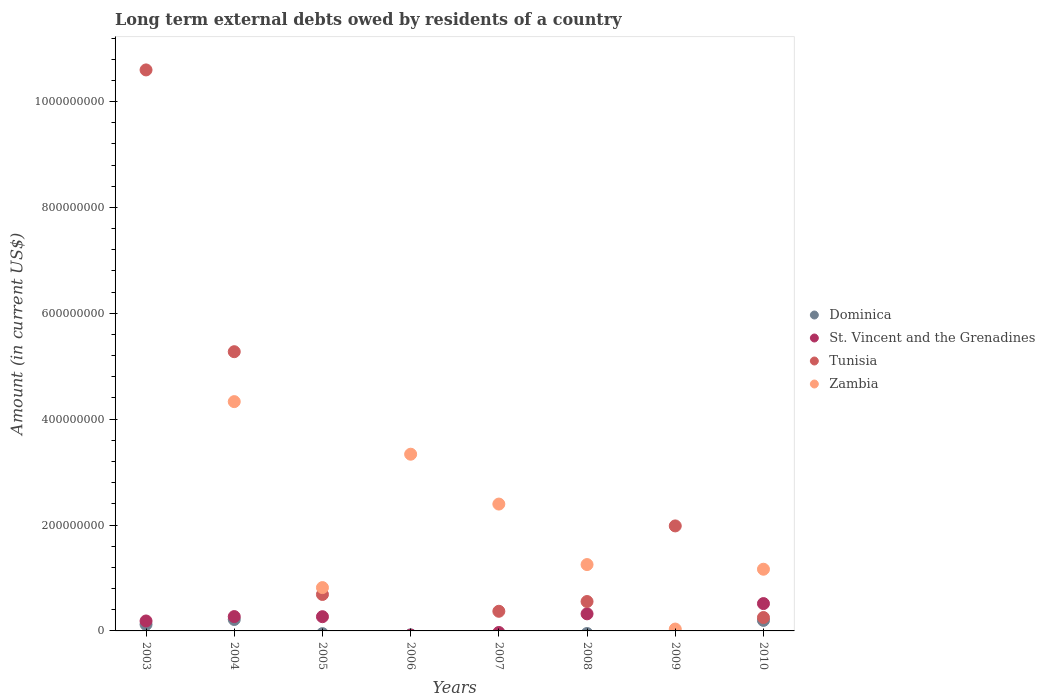Is the number of dotlines equal to the number of legend labels?
Your response must be concise. No. Across all years, what is the maximum amount of long-term external debts owed by residents in Zambia?
Your response must be concise. 4.33e+08. What is the total amount of long-term external debts owed by residents in Dominica in the graph?
Give a very brief answer. 5.37e+07. What is the difference between the amount of long-term external debts owed by residents in Zambia in 2005 and that in 2008?
Offer a terse response. -4.35e+07. What is the difference between the amount of long-term external debts owed by residents in Tunisia in 2008 and the amount of long-term external debts owed by residents in Zambia in 2009?
Provide a short and direct response. 5.20e+07. What is the average amount of long-term external debts owed by residents in Zambia per year?
Keep it short and to the point. 1.67e+08. In the year 2003, what is the difference between the amount of long-term external debts owed by residents in Tunisia and amount of long-term external debts owed by residents in Dominica?
Give a very brief answer. 1.05e+09. What is the ratio of the amount of long-term external debts owed by residents in Tunisia in 2004 to that in 2007?
Keep it short and to the point. 14.21. What is the difference between the highest and the second highest amount of long-term external debts owed by residents in Tunisia?
Ensure brevity in your answer.  5.32e+08. What is the difference between the highest and the lowest amount of long-term external debts owed by residents in Zambia?
Give a very brief answer. 4.33e+08. Is it the case that in every year, the sum of the amount of long-term external debts owed by residents in Tunisia and amount of long-term external debts owed by residents in St. Vincent and the Grenadines  is greater than the sum of amount of long-term external debts owed by residents in Zambia and amount of long-term external debts owed by residents in Dominica?
Keep it short and to the point. No. Is it the case that in every year, the sum of the amount of long-term external debts owed by residents in Tunisia and amount of long-term external debts owed by residents in Dominica  is greater than the amount of long-term external debts owed by residents in Zambia?
Offer a very short reply. No. Does the amount of long-term external debts owed by residents in Tunisia monotonically increase over the years?
Provide a short and direct response. No. How many dotlines are there?
Keep it short and to the point. 4. How are the legend labels stacked?
Ensure brevity in your answer.  Vertical. What is the title of the graph?
Your answer should be very brief. Long term external debts owed by residents of a country. What is the label or title of the Y-axis?
Offer a terse response. Amount (in current US$). What is the Amount (in current US$) in Dominica in 2003?
Make the answer very short. 1.23e+07. What is the Amount (in current US$) of St. Vincent and the Grenadines in 2003?
Your response must be concise. 1.88e+07. What is the Amount (in current US$) in Tunisia in 2003?
Your response must be concise. 1.06e+09. What is the Amount (in current US$) of Dominica in 2004?
Provide a succinct answer. 2.16e+07. What is the Amount (in current US$) in St. Vincent and the Grenadines in 2004?
Give a very brief answer. 2.71e+07. What is the Amount (in current US$) of Tunisia in 2004?
Keep it short and to the point. 5.27e+08. What is the Amount (in current US$) of Zambia in 2004?
Provide a short and direct response. 4.33e+08. What is the Amount (in current US$) of St. Vincent and the Grenadines in 2005?
Make the answer very short. 2.69e+07. What is the Amount (in current US$) in Tunisia in 2005?
Give a very brief answer. 6.89e+07. What is the Amount (in current US$) in Zambia in 2005?
Offer a terse response. 8.18e+07. What is the Amount (in current US$) in Dominica in 2006?
Your answer should be compact. 0. What is the Amount (in current US$) of St. Vincent and the Grenadines in 2006?
Offer a terse response. 0. What is the Amount (in current US$) of Zambia in 2006?
Provide a succinct answer. 3.34e+08. What is the Amount (in current US$) in Tunisia in 2007?
Give a very brief answer. 3.71e+07. What is the Amount (in current US$) in Zambia in 2007?
Provide a short and direct response. 2.40e+08. What is the Amount (in current US$) of Dominica in 2008?
Give a very brief answer. 0. What is the Amount (in current US$) of St. Vincent and the Grenadines in 2008?
Provide a succinct answer. 3.23e+07. What is the Amount (in current US$) of Tunisia in 2008?
Your response must be concise. 5.55e+07. What is the Amount (in current US$) of Zambia in 2008?
Your answer should be very brief. 1.25e+08. What is the Amount (in current US$) of St. Vincent and the Grenadines in 2009?
Give a very brief answer. 0. What is the Amount (in current US$) in Tunisia in 2009?
Make the answer very short. 1.98e+08. What is the Amount (in current US$) of Zambia in 2009?
Offer a very short reply. 3.52e+06. What is the Amount (in current US$) of Dominica in 2010?
Provide a succinct answer. 1.99e+07. What is the Amount (in current US$) in St. Vincent and the Grenadines in 2010?
Ensure brevity in your answer.  5.17e+07. What is the Amount (in current US$) in Tunisia in 2010?
Your response must be concise. 2.53e+07. What is the Amount (in current US$) of Zambia in 2010?
Your answer should be very brief. 1.17e+08. Across all years, what is the maximum Amount (in current US$) in Dominica?
Your answer should be very brief. 2.16e+07. Across all years, what is the maximum Amount (in current US$) of St. Vincent and the Grenadines?
Make the answer very short. 5.17e+07. Across all years, what is the maximum Amount (in current US$) in Tunisia?
Provide a short and direct response. 1.06e+09. Across all years, what is the maximum Amount (in current US$) in Zambia?
Provide a succinct answer. 4.33e+08. Across all years, what is the minimum Amount (in current US$) in Tunisia?
Offer a terse response. 0. What is the total Amount (in current US$) in Dominica in the graph?
Provide a succinct answer. 5.37e+07. What is the total Amount (in current US$) in St. Vincent and the Grenadines in the graph?
Give a very brief answer. 1.57e+08. What is the total Amount (in current US$) of Tunisia in the graph?
Give a very brief answer. 1.97e+09. What is the total Amount (in current US$) of Zambia in the graph?
Give a very brief answer. 1.33e+09. What is the difference between the Amount (in current US$) of Dominica in 2003 and that in 2004?
Give a very brief answer. -9.34e+06. What is the difference between the Amount (in current US$) in St. Vincent and the Grenadines in 2003 and that in 2004?
Your response must be concise. -8.30e+06. What is the difference between the Amount (in current US$) in Tunisia in 2003 and that in 2004?
Make the answer very short. 5.32e+08. What is the difference between the Amount (in current US$) in St. Vincent and the Grenadines in 2003 and that in 2005?
Your response must be concise. -8.10e+06. What is the difference between the Amount (in current US$) of Tunisia in 2003 and that in 2005?
Provide a succinct answer. 9.91e+08. What is the difference between the Amount (in current US$) of Tunisia in 2003 and that in 2007?
Your answer should be compact. 1.02e+09. What is the difference between the Amount (in current US$) of St. Vincent and the Grenadines in 2003 and that in 2008?
Ensure brevity in your answer.  -1.35e+07. What is the difference between the Amount (in current US$) in Tunisia in 2003 and that in 2008?
Give a very brief answer. 1.00e+09. What is the difference between the Amount (in current US$) of Tunisia in 2003 and that in 2009?
Make the answer very short. 8.61e+08. What is the difference between the Amount (in current US$) of Dominica in 2003 and that in 2010?
Your answer should be very brief. -7.62e+06. What is the difference between the Amount (in current US$) in St. Vincent and the Grenadines in 2003 and that in 2010?
Your response must be concise. -3.29e+07. What is the difference between the Amount (in current US$) in Tunisia in 2003 and that in 2010?
Provide a short and direct response. 1.03e+09. What is the difference between the Amount (in current US$) of St. Vincent and the Grenadines in 2004 and that in 2005?
Keep it short and to the point. 1.99e+05. What is the difference between the Amount (in current US$) of Tunisia in 2004 and that in 2005?
Make the answer very short. 4.59e+08. What is the difference between the Amount (in current US$) in Zambia in 2004 and that in 2005?
Your answer should be very brief. 3.51e+08. What is the difference between the Amount (in current US$) of Zambia in 2004 and that in 2006?
Provide a succinct answer. 9.93e+07. What is the difference between the Amount (in current US$) of Tunisia in 2004 and that in 2007?
Keep it short and to the point. 4.90e+08. What is the difference between the Amount (in current US$) of Zambia in 2004 and that in 2007?
Your answer should be very brief. 1.94e+08. What is the difference between the Amount (in current US$) in St. Vincent and the Grenadines in 2004 and that in 2008?
Keep it short and to the point. -5.20e+06. What is the difference between the Amount (in current US$) in Tunisia in 2004 and that in 2008?
Offer a terse response. 4.72e+08. What is the difference between the Amount (in current US$) of Zambia in 2004 and that in 2008?
Make the answer very short. 3.08e+08. What is the difference between the Amount (in current US$) in Tunisia in 2004 and that in 2009?
Keep it short and to the point. 3.29e+08. What is the difference between the Amount (in current US$) of Zambia in 2004 and that in 2009?
Your response must be concise. 4.30e+08. What is the difference between the Amount (in current US$) in Dominica in 2004 and that in 2010?
Provide a succinct answer. 1.71e+06. What is the difference between the Amount (in current US$) of St. Vincent and the Grenadines in 2004 and that in 2010?
Keep it short and to the point. -2.46e+07. What is the difference between the Amount (in current US$) of Tunisia in 2004 and that in 2010?
Give a very brief answer. 5.02e+08. What is the difference between the Amount (in current US$) of Zambia in 2004 and that in 2010?
Your answer should be very brief. 3.17e+08. What is the difference between the Amount (in current US$) of Zambia in 2005 and that in 2006?
Your response must be concise. -2.52e+08. What is the difference between the Amount (in current US$) in Tunisia in 2005 and that in 2007?
Provide a short and direct response. 3.18e+07. What is the difference between the Amount (in current US$) in Zambia in 2005 and that in 2007?
Ensure brevity in your answer.  -1.58e+08. What is the difference between the Amount (in current US$) in St. Vincent and the Grenadines in 2005 and that in 2008?
Give a very brief answer. -5.40e+06. What is the difference between the Amount (in current US$) in Tunisia in 2005 and that in 2008?
Offer a very short reply. 1.33e+07. What is the difference between the Amount (in current US$) of Zambia in 2005 and that in 2008?
Make the answer very short. -4.35e+07. What is the difference between the Amount (in current US$) in Tunisia in 2005 and that in 2009?
Offer a terse response. -1.29e+08. What is the difference between the Amount (in current US$) in Zambia in 2005 and that in 2009?
Ensure brevity in your answer.  7.83e+07. What is the difference between the Amount (in current US$) in St. Vincent and the Grenadines in 2005 and that in 2010?
Keep it short and to the point. -2.48e+07. What is the difference between the Amount (in current US$) in Tunisia in 2005 and that in 2010?
Keep it short and to the point. 4.36e+07. What is the difference between the Amount (in current US$) in Zambia in 2005 and that in 2010?
Give a very brief answer. -3.47e+07. What is the difference between the Amount (in current US$) of Zambia in 2006 and that in 2007?
Ensure brevity in your answer.  9.42e+07. What is the difference between the Amount (in current US$) of Zambia in 2006 and that in 2008?
Keep it short and to the point. 2.08e+08. What is the difference between the Amount (in current US$) in Zambia in 2006 and that in 2009?
Keep it short and to the point. 3.30e+08. What is the difference between the Amount (in current US$) of Zambia in 2006 and that in 2010?
Offer a very short reply. 2.17e+08. What is the difference between the Amount (in current US$) of Tunisia in 2007 and that in 2008?
Ensure brevity in your answer.  -1.84e+07. What is the difference between the Amount (in current US$) in Zambia in 2007 and that in 2008?
Ensure brevity in your answer.  1.14e+08. What is the difference between the Amount (in current US$) in Tunisia in 2007 and that in 2009?
Provide a succinct answer. -1.61e+08. What is the difference between the Amount (in current US$) of Zambia in 2007 and that in 2009?
Give a very brief answer. 2.36e+08. What is the difference between the Amount (in current US$) of Tunisia in 2007 and that in 2010?
Keep it short and to the point. 1.18e+07. What is the difference between the Amount (in current US$) in Zambia in 2007 and that in 2010?
Offer a very short reply. 1.23e+08. What is the difference between the Amount (in current US$) in Tunisia in 2008 and that in 2009?
Provide a short and direct response. -1.43e+08. What is the difference between the Amount (in current US$) in Zambia in 2008 and that in 2009?
Offer a terse response. 1.22e+08. What is the difference between the Amount (in current US$) of St. Vincent and the Grenadines in 2008 and that in 2010?
Offer a terse response. -1.94e+07. What is the difference between the Amount (in current US$) in Tunisia in 2008 and that in 2010?
Offer a very short reply. 3.02e+07. What is the difference between the Amount (in current US$) of Zambia in 2008 and that in 2010?
Offer a terse response. 8.81e+06. What is the difference between the Amount (in current US$) in Tunisia in 2009 and that in 2010?
Offer a very short reply. 1.73e+08. What is the difference between the Amount (in current US$) of Zambia in 2009 and that in 2010?
Provide a short and direct response. -1.13e+08. What is the difference between the Amount (in current US$) in Dominica in 2003 and the Amount (in current US$) in St. Vincent and the Grenadines in 2004?
Your answer should be compact. -1.48e+07. What is the difference between the Amount (in current US$) in Dominica in 2003 and the Amount (in current US$) in Tunisia in 2004?
Your answer should be very brief. -5.15e+08. What is the difference between the Amount (in current US$) of Dominica in 2003 and the Amount (in current US$) of Zambia in 2004?
Provide a succinct answer. -4.21e+08. What is the difference between the Amount (in current US$) in St. Vincent and the Grenadines in 2003 and the Amount (in current US$) in Tunisia in 2004?
Give a very brief answer. -5.09e+08. What is the difference between the Amount (in current US$) in St. Vincent and the Grenadines in 2003 and the Amount (in current US$) in Zambia in 2004?
Provide a succinct answer. -4.14e+08. What is the difference between the Amount (in current US$) in Tunisia in 2003 and the Amount (in current US$) in Zambia in 2004?
Offer a terse response. 6.27e+08. What is the difference between the Amount (in current US$) of Dominica in 2003 and the Amount (in current US$) of St. Vincent and the Grenadines in 2005?
Offer a terse response. -1.46e+07. What is the difference between the Amount (in current US$) in Dominica in 2003 and the Amount (in current US$) in Tunisia in 2005?
Give a very brief answer. -5.66e+07. What is the difference between the Amount (in current US$) of Dominica in 2003 and the Amount (in current US$) of Zambia in 2005?
Provide a succinct answer. -6.96e+07. What is the difference between the Amount (in current US$) of St. Vincent and the Grenadines in 2003 and the Amount (in current US$) of Tunisia in 2005?
Offer a very short reply. -5.01e+07. What is the difference between the Amount (in current US$) of St. Vincent and the Grenadines in 2003 and the Amount (in current US$) of Zambia in 2005?
Offer a terse response. -6.31e+07. What is the difference between the Amount (in current US$) of Tunisia in 2003 and the Amount (in current US$) of Zambia in 2005?
Offer a very short reply. 9.78e+08. What is the difference between the Amount (in current US$) of Dominica in 2003 and the Amount (in current US$) of Zambia in 2006?
Your response must be concise. -3.22e+08. What is the difference between the Amount (in current US$) in St. Vincent and the Grenadines in 2003 and the Amount (in current US$) in Zambia in 2006?
Make the answer very short. -3.15e+08. What is the difference between the Amount (in current US$) in Tunisia in 2003 and the Amount (in current US$) in Zambia in 2006?
Your response must be concise. 7.26e+08. What is the difference between the Amount (in current US$) of Dominica in 2003 and the Amount (in current US$) of Tunisia in 2007?
Provide a short and direct response. -2.48e+07. What is the difference between the Amount (in current US$) in Dominica in 2003 and the Amount (in current US$) in Zambia in 2007?
Provide a succinct answer. -2.27e+08. What is the difference between the Amount (in current US$) of St. Vincent and the Grenadines in 2003 and the Amount (in current US$) of Tunisia in 2007?
Provide a short and direct response. -1.83e+07. What is the difference between the Amount (in current US$) in St. Vincent and the Grenadines in 2003 and the Amount (in current US$) in Zambia in 2007?
Offer a very short reply. -2.21e+08. What is the difference between the Amount (in current US$) in Tunisia in 2003 and the Amount (in current US$) in Zambia in 2007?
Provide a short and direct response. 8.20e+08. What is the difference between the Amount (in current US$) in Dominica in 2003 and the Amount (in current US$) in St. Vincent and the Grenadines in 2008?
Ensure brevity in your answer.  -2.00e+07. What is the difference between the Amount (in current US$) in Dominica in 2003 and the Amount (in current US$) in Tunisia in 2008?
Give a very brief answer. -4.33e+07. What is the difference between the Amount (in current US$) of Dominica in 2003 and the Amount (in current US$) of Zambia in 2008?
Your response must be concise. -1.13e+08. What is the difference between the Amount (in current US$) in St. Vincent and the Grenadines in 2003 and the Amount (in current US$) in Tunisia in 2008?
Provide a succinct answer. -3.68e+07. What is the difference between the Amount (in current US$) of St. Vincent and the Grenadines in 2003 and the Amount (in current US$) of Zambia in 2008?
Provide a short and direct response. -1.07e+08. What is the difference between the Amount (in current US$) in Tunisia in 2003 and the Amount (in current US$) in Zambia in 2008?
Offer a terse response. 9.34e+08. What is the difference between the Amount (in current US$) of Dominica in 2003 and the Amount (in current US$) of Tunisia in 2009?
Your response must be concise. -1.86e+08. What is the difference between the Amount (in current US$) of Dominica in 2003 and the Amount (in current US$) of Zambia in 2009?
Offer a terse response. 8.74e+06. What is the difference between the Amount (in current US$) of St. Vincent and the Grenadines in 2003 and the Amount (in current US$) of Tunisia in 2009?
Provide a succinct answer. -1.80e+08. What is the difference between the Amount (in current US$) in St. Vincent and the Grenadines in 2003 and the Amount (in current US$) in Zambia in 2009?
Make the answer very short. 1.53e+07. What is the difference between the Amount (in current US$) of Tunisia in 2003 and the Amount (in current US$) of Zambia in 2009?
Give a very brief answer. 1.06e+09. What is the difference between the Amount (in current US$) of Dominica in 2003 and the Amount (in current US$) of St. Vincent and the Grenadines in 2010?
Provide a short and direct response. -3.94e+07. What is the difference between the Amount (in current US$) in Dominica in 2003 and the Amount (in current US$) in Tunisia in 2010?
Ensure brevity in your answer.  -1.30e+07. What is the difference between the Amount (in current US$) in Dominica in 2003 and the Amount (in current US$) in Zambia in 2010?
Provide a succinct answer. -1.04e+08. What is the difference between the Amount (in current US$) of St. Vincent and the Grenadines in 2003 and the Amount (in current US$) of Tunisia in 2010?
Your answer should be very brief. -6.52e+06. What is the difference between the Amount (in current US$) of St. Vincent and the Grenadines in 2003 and the Amount (in current US$) of Zambia in 2010?
Make the answer very short. -9.78e+07. What is the difference between the Amount (in current US$) in Tunisia in 2003 and the Amount (in current US$) in Zambia in 2010?
Offer a very short reply. 9.43e+08. What is the difference between the Amount (in current US$) of Dominica in 2004 and the Amount (in current US$) of St. Vincent and the Grenadines in 2005?
Make the answer very short. -5.28e+06. What is the difference between the Amount (in current US$) of Dominica in 2004 and the Amount (in current US$) of Tunisia in 2005?
Provide a short and direct response. -4.73e+07. What is the difference between the Amount (in current US$) in Dominica in 2004 and the Amount (in current US$) in Zambia in 2005?
Offer a very short reply. -6.03e+07. What is the difference between the Amount (in current US$) of St. Vincent and the Grenadines in 2004 and the Amount (in current US$) of Tunisia in 2005?
Your answer should be compact. -4.18e+07. What is the difference between the Amount (in current US$) of St. Vincent and the Grenadines in 2004 and the Amount (in current US$) of Zambia in 2005?
Give a very brief answer. -5.48e+07. What is the difference between the Amount (in current US$) of Tunisia in 2004 and the Amount (in current US$) of Zambia in 2005?
Provide a succinct answer. 4.46e+08. What is the difference between the Amount (in current US$) of Dominica in 2004 and the Amount (in current US$) of Zambia in 2006?
Ensure brevity in your answer.  -3.12e+08. What is the difference between the Amount (in current US$) in St. Vincent and the Grenadines in 2004 and the Amount (in current US$) in Zambia in 2006?
Keep it short and to the point. -3.07e+08. What is the difference between the Amount (in current US$) of Tunisia in 2004 and the Amount (in current US$) of Zambia in 2006?
Give a very brief answer. 1.94e+08. What is the difference between the Amount (in current US$) of Dominica in 2004 and the Amount (in current US$) of Tunisia in 2007?
Offer a very short reply. -1.55e+07. What is the difference between the Amount (in current US$) in Dominica in 2004 and the Amount (in current US$) in Zambia in 2007?
Keep it short and to the point. -2.18e+08. What is the difference between the Amount (in current US$) in St. Vincent and the Grenadines in 2004 and the Amount (in current US$) in Tunisia in 2007?
Your response must be concise. -1.00e+07. What is the difference between the Amount (in current US$) of St. Vincent and the Grenadines in 2004 and the Amount (in current US$) of Zambia in 2007?
Offer a terse response. -2.13e+08. What is the difference between the Amount (in current US$) in Tunisia in 2004 and the Amount (in current US$) in Zambia in 2007?
Your answer should be very brief. 2.88e+08. What is the difference between the Amount (in current US$) in Dominica in 2004 and the Amount (in current US$) in St. Vincent and the Grenadines in 2008?
Provide a short and direct response. -1.07e+07. What is the difference between the Amount (in current US$) in Dominica in 2004 and the Amount (in current US$) in Tunisia in 2008?
Keep it short and to the point. -3.39e+07. What is the difference between the Amount (in current US$) of Dominica in 2004 and the Amount (in current US$) of Zambia in 2008?
Give a very brief answer. -1.04e+08. What is the difference between the Amount (in current US$) of St. Vincent and the Grenadines in 2004 and the Amount (in current US$) of Tunisia in 2008?
Your answer should be compact. -2.84e+07. What is the difference between the Amount (in current US$) of St. Vincent and the Grenadines in 2004 and the Amount (in current US$) of Zambia in 2008?
Provide a short and direct response. -9.83e+07. What is the difference between the Amount (in current US$) in Tunisia in 2004 and the Amount (in current US$) in Zambia in 2008?
Provide a short and direct response. 4.02e+08. What is the difference between the Amount (in current US$) in Dominica in 2004 and the Amount (in current US$) in Tunisia in 2009?
Provide a succinct answer. -1.77e+08. What is the difference between the Amount (in current US$) of Dominica in 2004 and the Amount (in current US$) of Zambia in 2009?
Offer a terse response. 1.81e+07. What is the difference between the Amount (in current US$) of St. Vincent and the Grenadines in 2004 and the Amount (in current US$) of Tunisia in 2009?
Make the answer very short. -1.71e+08. What is the difference between the Amount (in current US$) of St. Vincent and the Grenadines in 2004 and the Amount (in current US$) of Zambia in 2009?
Your response must be concise. 2.36e+07. What is the difference between the Amount (in current US$) in Tunisia in 2004 and the Amount (in current US$) in Zambia in 2009?
Give a very brief answer. 5.24e+08. What is the difference between the Amount (in current US$) in Dominica in 2004 and the Amount (in current US$) in St. Vincent and the Grenadines in 2010?
Make the answer very short. -3.01e+07. What is the difference between the Amount (in current US$) of Dominica in 2004 and the Amount (in current US$) of Tunisia in 2010?
Make the answer very short. -3.70e+06. What is the difference between the Amount (in current US$) in Dominica in 2004 and the Amount (in current US$) in Zambia in 2010?
Provide a succinct answer. -9.49e+07. What is the difference between the Amount (in current US$) of St. Vincent and the Grenadines in 2004 and the Amount (in current US$) of Tunisia in 2010?
Your answer should be very brief. 1.78e+06. What is the difference between the Amount (in current US$) in St. Vincent and the Grenadines in 2004 and the Amount (in current US$) in Zambia in 2010?
Offer a very short reply. -8.95e+07. What is the difference between the Amount (in current US$) of Tunisia in 2004 and the Amount (in current US$) of Zambia in 2010?
Offer a terse response. 4.11e+08. What is the difference between the Amount (in current US$) in St. Vincent and the Grenadines in 2005 and the Amount (in current US$) in Zambia in 2006?
Make the answer very short. -3.07e+08. What is the difference between the Amount (in current US$) of Tunisia in 2005 and the Amount (in current US$) of Zambia in 2006?
Make the answer very short. -2.65e+08. What is the difference between the Amount (in current US$) of St. Vincent and the Grenadines in 2005 and the Amount (in current US$) of Tunisia in 2007?
Provide a succinct answer. -1.02e+07. What is the difference between the Amount (in current US$) of St. Vincent and the Grenadines in 2005 and the Amount (in current US$) of Zambia in 2007?
Provide a succinct answer. -2.13e+08. What is the difference between the Amount (in current US$) of Tunisia in 2005 and the Amount (in current US$) of Zambia in 2007?
Provide a short and direct response. -1.71e+08. What is the difference between the Amount (in current US$) in St. Vincent and the Grenadines in 2005 and the Amount (in current US$) in Tunisia in 2008?
Provide a succinct answer. -2.86e+07. What is the difference between the Amount (in current US$) of St. Vincent and the Grenadines in 2005 and the Amount (in current US$) of Zambia in 2008?
Ensure brevity in your answer.  -9.85e+07. What is the difference between the Amount (in current US$) of Tunisia in 2005 and the Amount (in current US$) of Zambia in 2008?
Your answer should be very brief. -5.65e+07. What is the difference between the Amount (in current US$) in St. Vincent and the Grenadines in 2005 and the Amount (in current US$) in Tunisia in 2009?
Give a very brief answer. -1.71e+08. What is the difference between the Amount (in current US$) in St. Vincent and the Grenadines in 2005 and the Amount (in current US$) in Zambia in 2009?
Offer a terse response. 2.34e+07. What is the difference between the Amount (in current US$) of Tunisia in 2005 and the Amount (in current US$) of Zambia in 2009?
Offer a terse response. 6.53e+07. What is the difference between the Amount (in current US$) in St. Vincent and the Grenadines in 2005 and the Amount (in current US$) in Tunisia in 2010?
Provide a short and direct response. 1.58e+06. What is the difference between the Amount (in current US$) in St. Vincent and the Grenadines in 2005 and the Amount (in current US$) in Zambia in 2010?
Your answer should be compact. -8.97e+07. What is the difference between the Amount (in current US$) in Tunisia in 2005 and the Amount (in current US$) in Zambia in 2010?
Offer a very short reply. -4.77e+07. What is the difference between the Amount (in current US$) in Tunisia in 2007 and the Amount (in current US$) in Zambia in 2008?
Your response must be concise. -8.82e+07. What is the difference between the Amount (in current US$) of Tunisia in 2007 and the Amount (in current US$) of Zambia in 2009?
Your response must be concise. 3.36e+07. What is the difference between the Amount (in current US$) of Tunisia in 2007 and the Amount (in current US$) of Zambia in 2010?
Keep it short and to the point. -7.94e+07. What is the difference between the Amount (in current US$) in St. Vincent and the Grenadines in 2008 and the Amount (in current US$) in Tunisia in 2009?
Ensure brevity in your answer.  -1.66e+08. What is the difference between the Amount (in current US$) in St. Vincent and the Grenadines in 2008 and the Amount (in current US$) in Zambia in 2009?
Provide a short and direct response. 2.88e+07. What is the difference between the Amount (in current US$) in Tunisia in 2008 and the Amount (in current US$) in Zambia in 2009?
Keep it short and to the point. 5.20e+07. What is the difference between the Amount (in current US$) of St. Vincent and the Grenadines in 2008 and the Amount (in current US$) of Tunisia in 2010?
Your response must be concise. 6.98e+06. What is the difference between the Amount (in current US$) of St. Vincent and the Grenadines in 2008 and the Amount (in current US$) of Zambia in 2010?
Make the answer very short. -8.43e+07. What is the difference between the Amount (in current US$) in Tunisia in 2008 and the Amount (in current US$) in Zambia in 2010?
Your answer should be very brief. -6.10e+07. What is the difference between the Amount (in current US$) of Tunisia in 2009 and the Amount (in current US$) of Zambia in 2010?
Offer a terse response. 8.18e+07. What is the average Amount (in current US$) of Dominica per year?
Your response must be concise. 6.72e+06. What is the average Amount (in current US$) in St. Vincent and the Grenadines per year?
Provide a short and direct response. 1.96e+07. What is the average Amount (in current US$) in Tunisia per year?
Offer a very short reply. 2.47e+08. What is the average Amount (in current US$) in Zambia per year?
Offer a very short reply. 1.67e+08. In the year 2003, what is the difference between the Amount (in current US$) in Dominica and Amount (in current US$) in St. Vincent and the Grenadines?
Your response must be concise. -6.52e+06. In the year 2003, what is the difference between the Amount (in current US$) of Dominica and Amount (in current US$) of Tunisia?
Ensure brevity in your answer.  -1.05e+09. In the year 2003, what is the difference between the Amount (in current US$) in St. Vincent and the Grenadines and Amount (in current US$) in Tunisia?
Ensure brevity in your answer.  -1.04e+09. In the year 2004, what is the difference between the Amount (in current US$) of Dominica and Amount (in current US$) of St. Vincent and the Grenadines?
Give a very brief answer. -5.48e+06. In the year 2004, what is the difference between the Amount (in current US$) in Dominica and Amount (in current US$) in Tunisia?
Keep it short and to the point. -5.06e+08. In the year 2004, what is the difference between the Amount (in current US$) in Dominica and Amount (in current US$) in Zambia?
Provide a short and direct response. -4.12e+08. In the year 2004, what is the difference between the Amount (in current US$) in St. Vincent and the Grenadines and Amount (in current US$) in Tunisia?
Keep it short and to the point. -5.00e+08. In the year 2004, what is the difference between the Amount (in current US$) in St. Vincent and the Grenadines and Amount (in current US$) in Zambia?
Make the answer very short. -4.06e+08. In the year 2004, what is the difference between the Amount (in current US$) of Tunisia and Amount (in current US$) of Zambia?
Your answer should be very brief. 9.43e+07. In the year 2005, what is the difference between the Amount (in current US$) of St. Vincent and the Grenadines and Amount (in current US$) of Tunisia?
Offer a very short reply. -4.20e+07. In the year 2005, what is the difference between the Amount (in current US$) of St. Vincent and the Grenadines and Amount (in current US$) of Zambia?
Offer a terse response. -5.50e+07. In the year 2005, what is the difference between the Amount (in current US$) of Tunisia and Amount (in current US$) of Zambia?
Keep it short and to the point. -1.30e+07. In the year 2007, what is the difference between the Amount (in current US$) in Tunisia and Amount (in current US$) in Zambia?
Ensure brevity in your answer.  -2.03e+08. In the year 2008, what is the difference between the Amount (in current US$) in St. Vincent and the Grenadines and Amount (in current US$) in Tunisia?
Your answer should be very brief. -2.33e+07. In the year 2008, what is the difference between the Amount (in current US$) of St. Vincent and the Grenadines and Amount (in current US$) of Zambia?
Your answer should be very brief. -9.31e+07. In the year 2008, what is the difference between the Amount (in current US$) of Tunisia and Amount (in current US$) of Zambia?
Offer a terse response. -6.98e+07. In the year 2009, what is the difference between the Amount (in current US$) of Tunisia and Amount (in current US$) of Zambia?
Your answer should be very brief. 1.95e+08. In the year 2010, what is the difference between the Amount (in current US$) in Dominica and Amount (in current US$) in St. Vincent and the Grenadines?
Ensure brevity in your answer.  -3.18e+07. In the year 2010, what is the difference between the Amount (in current US$) of Dominica and Amount (in current US$) of Tunisia?
Give a very brief answer. -5.42e+06. In the year 2010, what is the difference between the Amount (in current US$) of Dominica and Amount (in current US$) of Zambia?
Provide a succinct answer. -9.67e+07. In the year 2010, what is the difference between the Amount (in current US$) in St. Vincent and the Grenadines and Amount (in current US$) in Tunisia?
Ensure brevity in your answer.  2.63e+07. In the year 2010, what is the difference between the Amount (in current US$) in St. Vincent and the Grenadines and Amount (in current US$) in Zambia?
Provide a short and direct response. -6.49e+07. In the year 2010, what is the difference between the Amount (in current US$) in Tunisia and Amount (in current US$) in Zambia?
Make the answer very short. -9.12e+07. What is the ratio of the Amount (in current US$) in Dominica in 2003 to that in 2004?
Ensure brevity in your answer.  0.57. What is the ratio of the Amount (in current US$) in St. Vincent and the Grenadines in 2003 to that in 2004?
Make the answer very short. 0.69. What is the ratio of the Amount (in current US$) of Tunisia in 2003 to that in 2004?
Your answer should be very brief. 2.01. What is the ratio of the Amount (in current US$) of St. Vincent and the Grenadines in 2003 to that in 2005?
Make the answer very short. 0.7. What is the ratio of the Amount (in current US$) in Tunisia in 2003 to that in 2005?
Provide a short and direct response. 15.39. What is the ratio of the Amount (in current US$) in Tunisia in 2003 to that in 2007?
Your answer should be very brief. 28.56. What is the ratio of the Amount (in current US$) of St. Vincent and the Grenadines in 2003 to that in 2008?
Give a very brief answer. 0.58. What is the ratio of the Amount (in current US$) of Tunisia in 2003 to that in 2008?
Give a very brief answer. 19.08. What is the ratio of the Amount (in current US$) in Tunisia in 2003 to that in 2009?
Your answer should be very brief. 5.34. What is the ratio of the Amount (in current US$) in Dominica in 2003 to that in 2010?
Provide a short and direct response. 0.62. What is the ratio of the Amount (in current US$) of St. Vincent and the Grenadines in 2003 to that in 2010?
Give a very brief answer. 0.36. What is the ratio of the Amount (in current US$) in Tunisia in 2003 to that in 2010?
Give a very brief answer. 41.88. What is the ratio of the Amount (in current US$) of St. Vincent and the Grenadines in 2004 to that in 2005?
Provide a succinct answer. 1.01. What is the ratio of the Amount (in current US$) of Tunisia in 2004 to that in 2005?
Your answer should be very brief. 7.66. What is the ratio of the Amount (in current US$) of Zambia in 2004 to that in 2005?
Your answer should be very brief. 5.29. What is the ratio of the Amount (in current US$) of Zambia in 2004 to that in 2006?
Offer a terse response. 1.3. What is the ratio of the Amount (in current US$) of Tunisia in 2004 to that in 2007?
Your response must be concise. 14.21. What is the ratio of the Amount (in current US$) of Zambia in 2004 to that in 2007?
Your answer should be compact. 1.81. What is the ratio of the Amount (in current US$) of St. Vincent and the Grenadines in 2004 to that in 2008?
Ensure brevity in your answer.  0.84. What is the ratio of the Amount (in current US$) of Tunisia in 2004 to that in 2008?
Keep it short and to the point. 9.5. What is the ratio of the Amount (in current US$) of Zambia in 2004 to that in 2008?
Make the answer very short. 3.46. What is the ratio of the Amount (in current US$) in Tunisia in 2004 to that in 2009?
Your response must be concise. 2.66. What is the ratio of the Amount (in current US$) in Zambia in 2004 to that in 2009?
Your response must be concise. 122.91. What is the ratio of the Amount (in current US$) of Dominica in 2004 to that in 2010?
Provide a succinct answer. 1.09. What is the ratio of the Amount (in current US$) in St. Vincent and the Grenadines in 2004 to that in 2010?
Give a very brief answer. 0.52. What is the ratio of the Amount (in current US$) in Tunisia in 2004 to that in 2010?
Provide a succinct answer. 20.85. What is the ratio of the Amount (in current US$) of Zambia in 2004 to that in 2010?
Your answer should be very brief. 3.72. What is the ratio of the Amount (in current US$) in Zambia in 2005 to that in 2006?
Give a very brief answer. 0.25. What is the ratio of the Amount (in current US$) of Tunisia in 2005 to that in 2007?
Your response must be concise. 1.86. What is the ratio of the Amount (in current US$) in Zambia in 2005 to that in 2007?
Ensure brevity in your answer.  0.34. What is the ratio of the Amount (in current US$) of St. Vincent and the Grenadines in 2005 to that in 2008?
Give a very brief answer. 0.83. What is the ratio of the Amount (in current US$) in Tunisia in 2005 to that in 2008?
Make the answer very short. 1.24. What is the ratio of the Amount (in current US$) of Zambia in 2005 to that in 2008?
Give a very brief answer. 0.65. What is the ratio of the Amount (in current US$) in Tunisia in 2005 to that in 2009?
Ensure brevity in your answer.  0.35. What is the ratio of the Amount (in current US$) in Zambia in 2005 to that in 2009?
Offer a terse response. 23.23. What is the ratio of the Amount (in current US$) of St. Vincent and the Grenadines in 2005 to that in 2010?
Give a very brief answer. 0.52. What is the ratio of the Amount (in current US$) of Tunisia in 2005 to that in 2010?
Give a very brief answer. 2.72. What is the ratio of the Amount (in current US$) in Zambia in 2005 to that in 2010?
Provide a succinct answer. 0.7. What is the ratio of the Amount (in current US$) of Zambia in 2006 to that in 2007?
Offer a very short reply. 1.39. What is the ratio of the Amount (in current US$) of Zambia in 2006 to that in 2008?
Make the answer very short. 2.66. What is the ratio of the Amount (in current US$) of Zambia in 2006 to that in 2009?
Ensure brevity in your answer.  94.72. What is the ratio of the Amount (in current US$) of Zambia in 2006 to that in 2010?
Your response must be concise. 2.86. What is the ratio of the Amount (in current US$) in Tunisia in 2007 to that in 2008?
Make the answer very short. 0.67. What is the ratio of the Amount (in current US$) in Zambia in 2007 to that in 2008?
Your response must be concise. 1.91. What is the ratio of the Amount (in current US$) in Tunisia in 2007 to that in 2009?
Give a very brief answer. 0.19. What is the ratio of the Amount (in current US$) in Zambia in 2007 to that in 2009?
Provide a succinct answer. 68. What is the ratio of the Amount (in current US$) of Tunisia in 2007 to that in 2010?
Give a very brief answer. 1.47. What is the ratio of the Amount (in current US$) of Zambia in 2007 to that in 2010?
Give a very brief answer. 2.06. What is the ratio of the Amount (in current US$) in Tunisia in 2008 to that in 2009?
Provide a short and direct response. 0.28. What is the ratio of the Amount (in current US$) in Zambia in 2008 to that in 2009?
Your answer should be very brief. 35.57. What is the ratio of the Amount (in current US$) in St. Vincent and the Grenadines in 2008 to that in 2010?
Provide a succinct answer. 0.62. What is the ratio of the Amount (in current US$) of Tunisia in 2008 to that in 2010?
Keep it short and to the point. 2.19. What is the ratio of the Amount (in current US$) in Zambia in 2008 to that in 2010?
Ensure brevity in your answer.  1.08. What is the ratio of the Amount (in current US$) of Tunisia in 2009 to that in 2010?
Provide a short and direct response. 7.84. What is the ratio of the Amount (in current US$) of Zambia in 2009 to that in 2010?
Your answer should be very brief. 0.03. What is the difference between the highest and the second highest Amount (in current US$) in Dominica?
Your answer should be compact. 1.71e+06. What is the difference between the highest and the second highest Amount (in current US$) of St. Vincent and the Grenadines?
Ensure brevity in your answer.  1.94e+07. What is the difference between the highest and the second highest Amount (in current US$) of Tunisia?
Your answer should be compact. 5.32e+08. What is the difference between the highest and the second highest Amount (in current US$) in Zambia?
Your answer should be compact. 9.93e+07. What is the difference between the highest and the lowest Amount (in current US$) of Dominica?
Your answer should be compact. 2.16e+07. What is the difference between the highest and the lowest Amount (in current US$) of St. Vincent and the Grenadines?
Give a very brief answer. 5.17e+07. What is the difference between the highest and the lowest Amount (in current US$) in Tunisia?
Make the answer very short. 1.06e+09. What is the difference between the highest and the lowest Amount (in current US$) of Zambia?
Provide a succinct answer. 4.33e+08. 